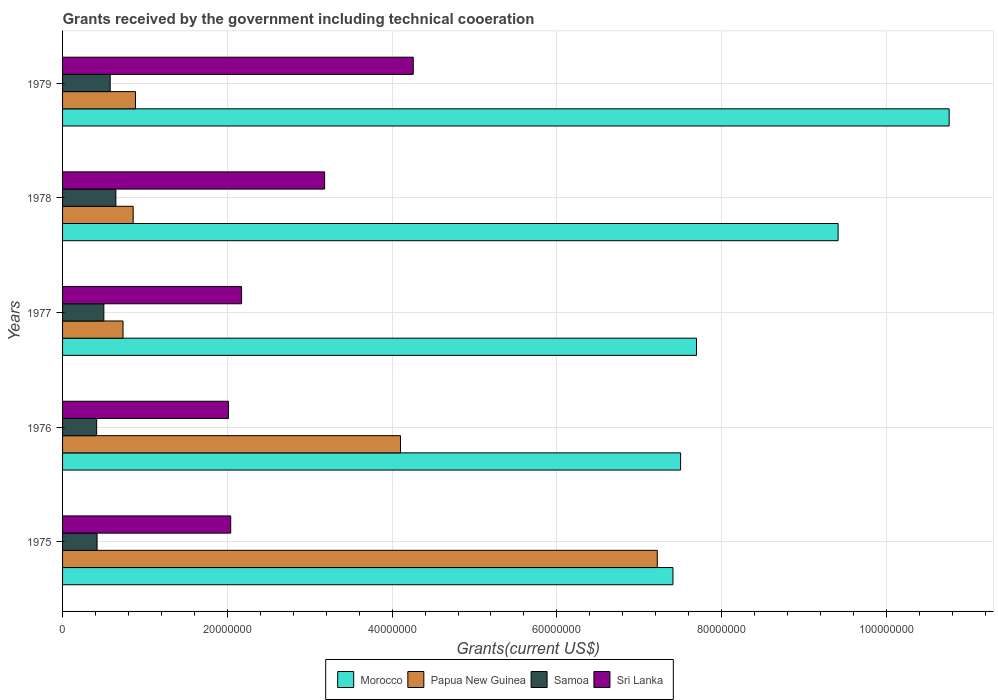How many groups of bars are there?
Make the answer very short. 5. How many bars are there on the 3rd tick from the top?
Your response must be concise. 4. How many bars are there on the 4th tick from the bottom?
Give a very brief answer. 4. In how many cases, is the number of bars for a given year not equal to the number of legend labels?
Your response must be concise. 0. What is the total grants received by the government in Samoa in 1978?
Your answer should be very brief. 6.47e+06. Across all years, what is the maximum total grants received by the government in Morocco?
Your response must be concise. 1.08e+08. Across all years, what is the minimum total grants received by the government in Sri Lanka?
Your response must be concise. 2.01e+07. In which year was the total grants received by the government in Papua New Guinea maximum?
Your response must be concise. 1975. In which year was the total grants received by the government in Samoa minimum?
Keep it short and to the point. 1976. What is the total total grants received by the government in Morocco in the graph?
Provide a short and direct response. 4.28e+08. What is the difference between the total grants received by the government in Papua New Guinea in 1975 and that in 1976?
Provide a succinct answer. 3.12e+07. What is the difference between the total grants received by the government in Sri Lanka in 1979 and the total grants received by the government in Samoa in 1975?
Give a very brief answer. 3.84e+07. What is the average total grants received by the government in Morocco per year?
Make the answer very short. 8.56e+07. In the year 1976, what is the difference between the total grants received by the government in Papua New Guinea and total grants received by the government in Sri Lanka?
Your answer should be very brief. 2.09e+07. What is the ratio of the total grants received by the government in Samoa in 1977 to that in 1978?
Offer a terse response. 0.77. What is the difference between the highest and the second highest total grants received by the government in Samoa?
Provide a succinct answer. 6.90e+05. What is the difference between the highest and the lowest total grants received by the government in Papua New Guinea?
Your answer should be very brief. 6.48e+07. In how many years, is the total grants received by the government in Papua New Guinea greater than the average total grants received by the government in Papua New Guinea taken over all years?
Make the answer very short. 2. Is the sum of the total grants received by the government in Morocco in 1975 and 1979 greater than the maximum total grants received by the government in Sri Lanka across all years?
Provide a succinct answer. Yes. What does the 3rd bar from the top in 1978 represents?
Offer a terse response. Papua New Guinea. What does the 1st bar from the bottom in 1975 represents?
Your answer should be compact. Morocco. Are all the bars in the graph horizontal?
Your response must be concise. Yes. How many years are there in the graph?
Make the answer very short. 5. What is the difference between two consecutive major ticks on the X-axis?
Provide a short and direct response. 2.00e+07. Where does the legend appear in the graph?
Your answer should be very brief. Bottom center. What is the title of the graph?
Your response must be concise. Grants received by the government including technical cooeration. Does "Mauritania" appear as one of the legend labels in the graph?
Offer a very short reply. No. What is the label or title of the X-axis?
Offer a very short reply. Grants(current US$). What is the Grants(current US$) of Morocco in 1975?
Make the answer very short. 7.41e+07. What is the Grants(current US$) of Papua New Guinea in 1975?
Offer a very short reply. 7.22e+07. What is the Grants(current US$) of Samoa in 1975?
Give a very brief answer. 4.19e+06. What is the Grants(current US$) in Sri Lanka in 1975?
Keep it short and to the point. 2.04e+07. What is the Grants(current US$) of Morocco in 1976?
Make the answer very short. 7.50e+07. What is the Grants(current US$) of Papua New Guinea in 1976?
Your answer should be very brief. 4.10e+07. What is the Grants(current US$) of Samoa in 1976?
Your response must be concise. 4.14e+06. What is the Grants(current US$) in Sri Lanka in 1976?
Ensure brevity in your answer.  2.01e+07. What is the Grants(current US$) in Morocco in 1977?
Your response must be concise. 7.70e+07. What is the Grants(current US$) of Papua New Guinea in 1977?
Provide a short and direct response. 7.34e+06. What is the Grants(current US$) in Samoa in 1977?
Make the answer very short. 5.01e+06. What is the Grants(current US$) in Sri Lanka in 1977?
Your answer should be compact. 2.17e+07. What is the Grants(current US$) of Morocco in 1978?
Offer a terse response. 9.41e+07. What is the Grants(current US$) of Papua New Guinea in 1978?
Your answer should be compact. 8.57e+06. What is the Grants(current US$) in Samoa in 1978?
Ensure brevity in your answer.  6.47e+06. What is the Grants(current US$) of Sri Lanka in 1978?
Your answer should be very brief. 3.18e+07. What is the Grants(current US$) in Morocco in 1979?
Make the answer very short. 1.08e+08. What is the Grants(current US$) of Papua New Guinea in 1979?
Ensure brevity in your answer.  8.85e+06. What is the Grants(current US$) of Samoa in 1979?
Provide a short and direct response. 5.78e+06. What is the Grants(current US$) in Sri Lanka in 1979?
Your answer should be compact. 4.26e+07. Across all years, what is the maximum Grants(current US$) of Morocco?
Offer a terse response. 1.08e+08. Across all years, what is the maximum Grants(current US$) of Papua New Guinea?
Offer a very short reply. 7.22e+07. Across all years, what is the maximum Grants(current US$) of Samoa?
Provide a short and direct response. 6.47e+06. Across all years, what is the maximum Grants(current US$) in Sri Lanka?
Ensure brevity in your answer.  4.26e+07. Across all years, what is the minimum Grants(current US$) of Morocco?
Your response must be concise. 7.41e+07. Across all years, what is the minimum Grants(current US$) of Papua New Guinea?
Keep it short and to the point. 7.34e+06. Across all years, what is the minimum Grants(current US$) in Samoa?
Keep it short and to the point. 4.14e+06. Across all years, what is the minimum Grants(current US$) in Sri Lanka?
Offer a very short reply. 2.01e+07. What is the total Grants(current US$) in Morocco in the graph?
Your response must be concise. 4.28e+08. What is the total Grants(current US$) in Papua New Guinea in the graph?
Offer a terse response. 1.38e+08. What is the total Grants(current US$) in Samoa in the graph?
Provide a succinct answer. 2.56e+07. What is the total Grants(current US$) in Sri Lanka in the graph?
Your response must be concise. 1.37e+08. What is the difference between the Grants(current US$) of Morocco in 1975 and that in 1976?
Offer a terse response. -9.30e+05. What is the difference between the Grants(current US$) of Papua New Guinea in 1975 and that in 1976?
Offer a very short reply. 3.12e+07. What is the difference between the Grants(current US$) in Samoa in 1975 and that in 1976?
Your answer should be compact. 5.00e+04. What is the difference between the Grants(current US$) of Sri Lanka in 1975 and that in 1976?
Provide a short and direct response. 2.70e+05. What is the difference between the Grants(current US$) in Morocco in 1975 and that in 1977?
Your answer should be very brief. -2.86e+06. What is the difference between the Grants(current US$) of Papua New Guinea in 1975 and that in 1977?
Provide a succinct answer. 6.48e+07. What is the difference between the Grants(current US$) in Samoa in 1975 and that in 1977?
Give a very brief answer. -8.20e+05. What is the difference between the Grants(current US$) of Sri Lanka in 1975 and that in 1977?
Ensure brevity in your answer.  -1.32e+06. What is the difference between the Grants(current US$) of Morocco in 1975 and that in 1978?
Offer a terse response. -2.00e+07. What is the difference between the Grants(current US$) of Papua New Guinea in 1975 and that in 1978?
Your answer should be very brief. 6.36e+07. What is the difference between the Grants(current US$) in Samoa in 1975 and that in 1978?
Give a very brief answer. -2.28e+06. What is the difference between the Grants(current US$) in Sri Lanka in 1975 and that in 1978?
Your answer should be very brief. -1.14e+07. What is the difference between the Grants(current US$) in Morocco in 1975 and that in 1979?
Your response must be concise. -3.35e+07. What is the difference between the Grants(current US$) in Papua New Guinea in 1975 and that in 1979?
Your answer should be very brief. 6.33e+07. What is the difference between the Grants(current US$) in Samoa in 1975 and that in 1979?
Keep it short and to the point. -1.59e+06. What is the difference between the Grants(current US$) in Sri Lanka in 1975 and that in 1979?
Offer a very short reply. -2.22e+07. What is the difference between the Grants(current US$) of Morocco in 1976 and that in 1977?
Provide a short and direct response. -1.93e+06. What is the difference between the Grants(current US$) of Papua New Guinea in 1976 and that in 1977?
Your answer should be very brief. 3.37e+07. What is the difference between the Grants(current US$) of Samoa in 1976 and that in 1977?
Provide a succinct answer. -8.70e+05. What is the difference between the Grants(current US$) in Sri Lanka in 1976 and that in 1977?
Make the answer very short. -1.59e+06. What is the difference between the Grants(current US$) in Morocco in 1976 and that in 1978?
Your response must be concise. -1.91e+07. What is the difference between the Grants(current US$) in Papua New Guinea in 1976 and that in 1978?
Provide a succinct answer. 3.24e+07. What is the difference between the Grants(current US$) of Samoa in 1976 and that in 1978?
Give a very brief answer. -2.33e+06. What is the difference between the Grants(current US$) of Sri Lanka in 1976 and that in 1978?
Make the answer very short. -1.17e+07. What is the difference between the Grants(current US$) in Morocco in 1976 and that in 1979?
Your answer should be compact. -3.26e+07. What is the difference between the Grants(current US$) of Papua New Guinea in 1976 and that in 1979?
Provide a short and direct response. 3.22e+07. What is the difference between the Grants(current US$) in Samoa in 1976 and that in 1979?
Offer a terse response. -1.64e+06. What is the difference between the Grants(current US$) in Sri Lanka in 1976 and that in 1979?
Keep it short and to the point. -2.24e+07. What is the difference between the Grants(current US$) in Morocco in 1977 and that in 1978?
Your answer should be very brief. -1.72e+07. What is the difference between the Grants(current US$) in Papua New Guinea in 1977 and that in 1978?
Ensure brevity in your answer.  -1.23e+06. What is the difference between the Grants(current US$) of Samoa in 1977 and that in 1978?
Provide a succinct answer. -1.46e+06. What is the difference between the Grants(current US$) in Sri Lanka in 1977 and that in 1978?
Give a very brief answer. -1.01e+07. What is the difference between the Grants(current US$) in Morocco in 1977 and that in 1979?
Give a very brief answer. -3.07e+07. What is the difference between the Grants(current US$) in Papua New Guinea in 1977 and that in 1979?
Provide a succinct answer. -1.51e+06. What is the difference between the Grants(current US$) in Samoa in 1977 and that in 1979?
Give a very brief answer. -7.70e+05. What is the difference between the Grants(current US$) in Sri Lanka in 1977 and that in 1979?
Provide a succinct answer. -2.08e+07. What is the difference between the Grants(current US$) in Morocco in 1978 and that in 1979?
Keep it short and to the point. -1.35e+07. What is the difference between the Grants(current US$) in Papua New Guinea in 1978 and that in 1979?
Keep it short and to the point. -2.80e+05. What is the difference between the Grants(current US$) in Samoa in 1978 and that in 1979?
Offer a very short reply. 6.90e+05. What is the difference between the Grants(current US$) in Sri Lanka in 1978 and that in 1979?
Make the answer very short. -1.08e+07. What is the difference between the Grants(current US$) of Morocco in 1975 and the Grants(current US$) of Papua New Guinea in 1976?
Give a very brief answer. 3.31e+07. What is the difference between the Grants(current US$) in Morocco in 1975 and the Grants(current US$) in Samoa in 1976?
Make the answer very short. 7.00e+07. What is the difference between the Grants(current US$) in Morocco in 1975 and the Grants(current US$) in Sri Lanka in 1976?
Offer a terse response. 5.40e+07. What is the difference between the Grants(current US$) of Papua New Guinea in 1975 and the Grants(current US$) of Samoa in 1976?
Offer a terse response. 6.80e+07. What is the difference between the Grants(current US$) in Papua New Guinea in 1975 and the Grants(current US$) in Sri Lanka in 1976?
Offer a terse response. 5.20e+07. What is the difference between the Grants(current US$) in Samoa in 1975 and the Grants(current US$) in Sri Lanka in 1976?
Provide a succinct answer. -1.60e+07. What is the difference between the Grants(current US$) of Morocco in 1975 and the Grants(current US$) of Papua New Guinea in 1977?
Your answer should be compact. 6.68e+07. What is the difference between the Grants(current US$) of Morocco in 1975 and the Grants(current US$) of Samoa in 1977?
Offer a very short reply. 6.91e+07. What is the difference between the Grants(current US$) in Morocco in 1975 and the Grants(current US$) in Sri Lanka in 1977?
Give a very brief answer. 5.24e+07. What is the difference between the Grants(current US$) in Papua New Guinea in 1975 and the Grants(current US$) in Samoa in 1977?
Provide a short and direct response. 6.72e+07. What is the difference between the Grants(current US$) in Papua New Guinea in 1975 and the Grants(current US$) in Sri Lanka in 1977?
Make the answer very short. 5.05e+07. What is the difference between the Grants(current US$) in Samoa in 1975 and the Grants(current US$) in Sri Lanka in 1977?
Your response must be concise. -1.75e+07. What is the difference between the Grants(current US$) of Morocco in 1975 and the Grants(current US$) of Papua New Guinea in 1978?
Your answer should be compact. 6.55e+07. What is the difference between the Grants(current US$) of Morocco in 1975 and the Grants(current US$) of Samoa in 1978?
Offer a very short reply. 6.76e+07. What is the difference between the Grants(current US$) of Morocco in 1975 and the Grants(current US$) of Sri Lanka in 1978?
Your answer should be very brief. 4.23e+07. What is the difference between the Grants(current US$) of Papua New Guinea in 1975 and the Grants(current US$) of Samoa in 1978?
Your response must be concise. 6.57e+07. What is the difference between the Grants(current US$) in Papua New Guinea in 1975 and the Grants(current US$) in Sri Lanka in 1978?
Ensure brevity in your answer.  4.04e+07. What is the difference between the Grants(current US$) in Samoa in 1975 and the Grants(current US$) in Sri Lanka in 1978?
Your answer should be compact. -2.76e+07. What is the difference between the Grants(current US$) of Morocco in 1975 and the Grants(current US$) of Papua New Guinea in 1979?
Ensure brevity in your answer.  6.52e+07. What is the difference between the Grants(current US$) of Morocco in 1975 and the Grants(current US$) of Samoa in 1979?
Provide a succinct answer. 6.83e+07. What is the difference between the Grants(current US$) of Morocco in 1975 and the Grants(current US$) of Sri Lanka in 1979?
Offer a terse response. 3.15e+07. What is the difference between the Grants(current US$) in Papua New Guinea in 1975 and the Grants(current US$) in Samoa in 1979?
Your response must be concise. 6.64e+07. What is the difference between the Grants(current US$) in Papua New Guinea in 1975 and the Grants(current US$) in Sri Lanka in 1979?
Your response must be concise. 2.96e+07. What is the difference between the Grants(current US$) in Samoa in 1975 and the Grants(current US$) in Sri Lanka in 1979?
Offer a terse response. -3.84e+07. What is the difference between the Grants(current US$) of Morocco in 1976 and the Grants(current US$) of Papua New Guinea in 1977?
Your answer should be compact. 6.77e+07. What is the difference between the Grants(current US$) of Morocco in 1976 and the Grants(current US$) of Samoa in 1977?
Make the answer very short. 7.00e+07. What is the difference between the Grants(current US$) of Morocco in 1976 and the Grants(current US$) of Sri Lanka in 1977?
Offer a terse response. 5.33e+07. What is the difference between the Grants(current US$) of Papua New Guinea in 1976 and the Grants(current US$) of Samoa in 1977?
Give a very brief answer. 3.60e+07. What is the difference between the Grants(current US$) in Papua New Guinea in 1976 and the Grants(current US$) in Sri Lanka in 1977?
Your answer should be very brief. 1.93e+07. What is the difference between the Grants(current US$) in Samoa in 1976 and the Grants(current US$) in Sri Lanka in 1977?
Offer a terse response. -1.76e+07. What is the difference between the Grants(current US$) in Morocco in 1976 and the Grants(current US$) in Papua New Guinea in 1978?
Offer a terse response. 6.64e+07. What is the difference between the Grants(current US$) of Morocco in 1976 and the Grants(current US$) of Samoa in 1978?
Your answer should be compact. 6.86e+07. What is the difference between the Grants(current US$) in Morocco in 1976 and the Grants(current US$) in Sri Lanka in 1978?
Offer a very short reply. 4.32e+07. What is the difference between the Grants(current US$) in Papua New Guinea in 1976 and the Grants(current US$) in Samoa in 1978?
Offer a very short reply. 3.46e+07. What is the difference between the Grants(current US$) in Papua New Guinea in 1976 and the Grants(current US$) in Sri Lanka in 1978?
Your response must be concise. 9.21e+06. What is the difference between the Grants(current US$) in Samoa in 1976 and the Grants(current US$) in Sri Lanka in 1978?
Provide a succinct answer. -2.77e+07. What is the difference between the Grants(current US$) in Morocco in 1976 and the Grants(current US$) in Papua New Guinea in 1979?
Your response must be concise. 6.62e+07. What is the difference between the Grants(current US$) of Morocco in 1976 and the Grants(current US$) of Samoa in 1979?
Your response must be concise. 6.92e+07. What is the difference between the Grants(current US$) of Morocco in 1976 and the Grants(current US$) of Sri Lanka in 1979?
Offer a terse response. 3.24e+07. What is the difference between the Grants(current US$) in Papua New Guinea in 1976 and the Grants(current US$) in Samoa in 1979?
Ensure brevity in your answer.  3.52e+07. What is the difference between the Grants(current US$) of Papua New Guinea in 1976 and the Grants(current US$) of Sri Lanka in 1979?
Provide a succinct answer. -1.55e+06. What is the difference between the Grants(current US$) in Samoa in 1976 and the Grants(current US$) in Sri Lanka in 1979?
Your answer should be compact. -3.84e+07. What is the difference between the Grants(current US$) in Morocco in 1977 and the Grants(current US$) in Papua New Guinea in 1978?
Provide a succinct answer. 6.84e+07. What is the difference between the Grants(current US$) of Morocco in 1977 and the Grants(current US$) of Samoa in 1978?
Give a very brief answer. 7.05e+07. What is the difference between the Grants(current US$) of Morocco in 1977 and the Grants(current US$) of Sri Lanka in 1978?
Your answer should be very brief. 4.51e+07. What is the difference between the Grants(current US$) of Papua New Guinea in 1977 and the Grants(current US$) of Samoa in 1978?
Make the answer very short. 8.70e+05. What is the difference between the Grants(current US$) of Papua New Guinea in 1977 and the Grants(current US$) of Sri Lanka in 1978?
Your response must be concise. -2.45e+07. What is the difference between the Grants(current US$) in Samoa in 1977 and the Grants(current US$) in Sri Lanka in 1978?
Offer a terse response. -2.68e+07. What is the difference between the Grants(current US$) of Morocco in 1977 and the Grants(current US$) of Papua New Guinea in 1979?
Offer a terse response. 6.81e+07. What is the difference between the Grants(current US$) in Morocco in 1977 and the Grants(current US$) in Samoa in 1979?
Give a very brief answer. 7.12e+07. What is the difference between the Grants(current US$) in Morocco in 1977 and the Grants(current US$) in Sri Lanka in 1979?
Provide a succinct answer. 3.44e+07. What is the difference between the Grants(current US$) of Papua New Guinea in 1977 and the Grants(current US$) of Samoa in 1979?
Offer a terse response. 1.56e+06. What is the difference between the Grants(current US$) in Papua New Guinea in 1977 and the Grants(current US$) in Sri Lanka in 1979?
Your answer should be compact. -3.52e+07. What is the difference between the Grants(current US$) in Samoa in 1977 and the Grants(current US$) in Sri Lanka in 1979?
Provide a succinct answer. -3.76e+07. What is the difference between the Grants(current US$) of Morocco in 1978 and the Grants(current US$) of Papua New Guinea in 1979?
Offer a very short reply. 8.53e+07. What is the difference between the Grants(current US$) in Morocco in 1978 and the Grants(current US$) in Samoa in 1979?
Offer a very short reply. 8.84e+07. What is the difference between the Grants(current US$) of Morocco in 1978 and the Grants(current US$) of Sri Lanka in 1979?
Give a very brief answer. 5.16e+07. What is the difference between the Grants(current US$) in Papua New Guinea in 1978 and the Grants(current US$) in Samoa in 1979?
Your response must be concise. 2.79e+06. What is the difference between the Grants(current US$) of Papua New Guinea in 1978 and the Grants(current US$) of Sri Lanka in 1979?
Your answer should be compact. -3.40e+07. What is the difference between the Grants(current US$) of Samoa in 1978 and the Grants(current US$) of Sri Lanka in 1979?
Offer a very short reply. -3.61e+07. What is the average Grants(current US$) in Morocco per year?
Ensure brevity in your answer.  8.56e+07. What is the average Grants(current US$) of Papua New Guinea per year?
Give a very brief answer. 2.76e+07. What is the average Grants(current US$) in Samoa per year?
Your answer should be very brief. 5.12e+06. What is the average Grants(current US$) in Sri Lanka per year?
Make the answer very short. 2.73e+07. In the year 1975, what is the difference between the Grants(current US$) in Morocco and Grants(current US$) in Papua New Guinea?
Offer a terse response. 1.90e+06. In the year 1975, what is the difference between the Grants(current US$) in Morocco and Grants(current US$) in Samoa?
Your response must be concise. 6.99e+07. In the year 1975, what is the difference between the Grants(current US$) in Morocco and Grants(current US$) in Sri Lanka?
Ensure brevity in your answer.  5.37e+07. In the year 1975, what is the difference between the Grants(current US$) of Papua New Guinea and Grants(current US$) of Samoa?
Keep it short and to the point. 6.80e+07. In the year 1975, what is the difference between the Grants(current US$) of Papua New Guinea and Grants(current US$) of Sri Lanka?
Keep it short and to the point. 5.18e+07. In the year 1975, what is the difference between the Grants(current US$) of Samoa and Grants(current US$) of Sri Lanka?
Keep it short and to the point. -1.62e+07. In the year 1976, what is the difference between the Grants(current US$) in Morocco and Grants(current US$) in Papua New Guinea?
Offer a terse response. 3.40e+07. In the year 1976, what is the difference between the Grants(current US$) of Morocco and Grants(current US$) of Samoa?
Make the answer very short. 7.09e+07. In the year 1976, what is the difference between the Grants(current US$) in Morocco and Grants(current US$) in Sri Lanka?
Your response must be concise. 5.49e+07. In the year 1976, what is the difference between the Grants(current US$) in Papua New Guinea and Grants(current US$) in Samoa?
Your answer should be very brief. 3.69e+07. In the year 1976, what is the difference between the Grants(current US$) of Papua New Guinea and Grants(current US$) of Sri Lanka?
Provide a short and direct response. 2.09e+07. In the year 1976, what is the difference between the Grants(current US$) in Samoa and Grants(current US$) in Sri Lanka?
Provide a short and direct response. -1.60e+07. In the year 1977, what is the difference between the Grants(current US$) in Morocco and Grants(current US$) in Papua New Guinea?
Your response must be concise. 6.96e+07. In the year 1977, what is the difference between the Grants(current US$) in Morocco and Grants(current US$) in Samoa?
Provide a short and direct response. 7.19e+07. In the year 1977, what is the difference between the Grants(current US$) of Morocco and Grants(current US$) of Sri Lanka?
Provide a short and direct response. 5.52e+07. In the year 1977, what is the difference between the Grants(current US$) in Papua New Guinea and Grants(current US$) in Samoa?
Make the answer very short. 2.33e+06. In the year 1977, what is the difference between the Grants(current US$) of Papua New Guinea and Grants(current US$) of Sri Lanka?
Your answer should be very brief. -1.44e+07. In the year 1977, what is the difference between the Grants(current US$) in Samoa and Grants(current US$) in Sri Lanka?
Your response must be concise. -1.67e+07. In the year 1978, what is the difference between the Grants(current US$) in Morocco and Grants(current US$) in Papua New Guinea?
Ensure brevity in your answer.  8.56e+07. In the year 1978, what is the difference between the Grants(current US$) in Morocco and Grants(current US$) in Samoa?
Offer a terse response. 8.77e+07. In the year 1978, what is the difference between the Grants(current US$) in Morocco and Grants(current US$) in Sri Lanka?
Provide a short and direct response. 6.23e+07. In the year 1978, what is the difference between the Grants(current US$) in Papua New Guinea and Grants(current US$) in Samoa?
Offer a terse response. 2.10e+06. In the year 1978, what is the difference between the Grants(current US$) of Papua New Guinea and Grants(current US$) of Sri Lanka?
Provide a short and direct response. -2.32e+07. In the year 1978, what is the difference between the Grants(current US$) in Samoa and Grants(current US$) in Sri Lanka?
Provide a short and direct response. -2.53e+07. In the year 1979, what is the difference between the Grants(current US$) of Morocco and Grants(current US$) of Papua New Guinea?
Your answer should be very brief. 9.88e+07. In the year 1979, what is the difference between the Grants(current US$) in Morocco and Grants(current US$) in Samoa?
Your response must be concise. 1.02e+08. In the year 1979, what is the difference between the Grants(current US$) of Morocco and Grants(current US$) of Sri Lanka?
Your answer should be compact. 6.50e+07. In the year 1979, what is the difference between the Grants(current US$) of Papua New Guinea and Grants(current US$) of Samoa?
Your response must be concise. 3.07e+06. In the year 1979, what is the difference between the Grants(current US$) in Papua New Guinea and Grants(current US$) in Sri Lanka?
Provide a short and direct response. -3.37e+07. In the year 1979, what is the difference between the Grants(current US$) in Samoa and Grants(current US$) in Sri Lanka?
Keep it short and to the point. -3.68e+07. What is the ratio of the Grants(current US$) in Morocco in 1975 to that in 1976?
Provide a short and direct response. 0.99. What is the ratio of the Grants(current US$) in Papua New Guinea in 1975 to that in 1976?
Offer a terse response. 1.76. What is the ratio of the Grants(current US$) in Samoa in 1975 to that in 1976?
Your answer should be compact. 1.01. What is the ratio of the Grants(current US$) of Sri Lanka in 1975 to that in 1976?
Provide a short and direct response. 1.01. What is the ratio of the Grants(current US$) of Morocco in 1975 to that in 1977?
Ensure brevity in your answer.  0.96. What is the ratio of the Grants(current US$) in Papua New Guinea in 1975 to that in 1977?
Provide a short and direct response. 9.84. What is the ratio of the Grants(current US$) in Samoa in 1975 to that in 1977?
Your response must be concise. 0.84. What is the ratio of the Grants(current US$) of Sri Lanka in 1975 to that in 1977?
Give a very brief answer. 0.94. What is the ratio of the Grants(current US$) in Morocco in 1975 to that in 1978?
Offer a very short reply. 0.79. What is the ratio of the Grants(current US$) of Papua New Guinea in 1975 to that in 1978?
Keep it short and to the point. 8.42. What is the ratio of the Grants(current US$) of Samoa in 1975 to that in 1978?
Provide a succinct answer. 0.65. What is the ratio of the Grants(current US$) of Sri Lanka in 1975 to that in 1978?
Offer a very short reply. 0.64. What is the ratio of the Grants(current US$) of Morocco in 1975 to that in 1979?
Offer a terse response. 0.69. What is the ratio of the Grants(current US$) of Papua New Guinea in 1975 to that in 1979?
Your answer should be compact. 8.16. What is the ratio of the Grants(current US$) in Samoa in 1975 to that in 1979?
Provide a succinct answer. 0.72. What is the ratio of the Grants(current US$) of Sri Lanka in 1975 to that in 1979?
Offer a very short reply. 0.48. What is the ratio of the Grants(current US$) of Morocco in 1976 to that in 1977?
Your response must be concise. 0.97. What is the ratio of the Grants(current US$) in Papua New Guinea in 1976 to that in 1977?
Give a very brief answer. 5.59. What is the ratio of the Grants(current US$) in Samoa in 1976 to that in 1977?
Provide a succinct answer. 0.83. What is the ratio of the Grants(current US$) of Sri Lanka in 1976 to that in 1977?
Give a very brief answer. 0.93. What is the ratio of the Grants(current US$) of Morocco in 1976 to that in 1978?
Your response must be concise. 0.8. What is the ratio of the Grants(current US$) in Papua New Guinea in 1976 to that in 1978?
Your answer should be very brief. 4.79. What is the ratio of the Grants(current US$) of Samoa in 1976 to that in 1978?
Provide a short and direct response. 0.64. What is the ratio of the Grants(current US$) in Sri Lanka in 1976 to that in 1978?
Provide a short and direct response. 0.63. What is the ratio of the Grants(current US$) of Morocco in 1976 to that in 1979?
Ensure brevity in your answer.  0.7. What is the ratio of the Grants(current US$) of Papua New Guinea in 1976 to that in 1979?
Provide a short and direct response. 4.63. What is the ratio of the Grants(current US$) of Samoa in 1976 to that in 1979?
Your answer should be compact. 0.72. What is the ratio of the Grants(current US$) of Sri Lanka in 1976 to that in 1979?
Give a very brief answer. 0.47. What is the ratio of the Grants(current US$) of Morocco in 1977 to that in 1978?
Your response must be concise. 0.82. What is the ratio of the Grants(current US$) in Papua New Guinea in 1977 to that in 1978?
Give a very brief answer. 0.86. What is the ratio of the Grants(current US$) in Samoa in 1977 to that in 1978?
Your answer should be compact. 0.77. What is the ratio of the Grants(current US$) in Sri Lanka in 1977 to that in 1978?
Your response must be concise. 0.68. What is the ratio of the Grants(current US$) of Morocco in 1977 to that in 1979?
Your answer should be compact. 0.71. What is the ratio of the Grants(current US$) of Papua New Guinea in 1977 to that in 1979?
Provide a succinct answer. 0.83. What is the ratio of the Grants(current US$) in Samoa in 1977 to that in 1979?
Provide a succinct answer. 0.87. What is the ratio of the Grants(current US$) of Sri Lanka in 1977 to that in 1979?
Ensure brevity in your answer.  0.51. What is the ratio of the Grants(current US$) in Morocco in 1978 to that in 1979?
Offer a very short reply. 0.87. What is the ratio of the Grants(current US$) in Papua New Guinea in 1978 to that in 1979?
Keep it short and to the point. 0.97. What is the ratio of the Grants(current US$) in Samoa in 1978 to that in 1979?
Make the answer very short. 1.12. What is the ratio of the Grants(current US$) in Sri Lanka in 1978 to that in 1979?
Offer a very short reply. 0.75. What is the difference between the highest and the second highest Grants(current US$) in Morocco?
Your answer should be very brief. 1.35e+07. What is the difference between the highest and the second highest Grants(current US$) of Papua New Guinea?
Make the answer very short. 3.12e+07. What is the difference between the highest and the second highest Grants(current US$) of Samoa?
Offer a terse response. 6.90e+05. What is the difference between the highest and the second highest Grants(current US$) in Sri Lanka?
Give a very brief answer. 1.08e+07. What is the difference between the highest and the lowest Grants(current US$) of Morocco?
Provide a short and direct response. 3.35e+07. What is the difference between the highest and the lowest Grants(current US$) in Papua New Guinea?
Offer a very short reply. 6.48e+07. What is the difference between the highest and the lowest Grants(current US$) in Samoa?
Offer a terse response. 2.33e+06. What is the difference between the highest and the lowest Grants(current US$) of Sri Lanka?
Offer a very short reply. 2.24e+07. 